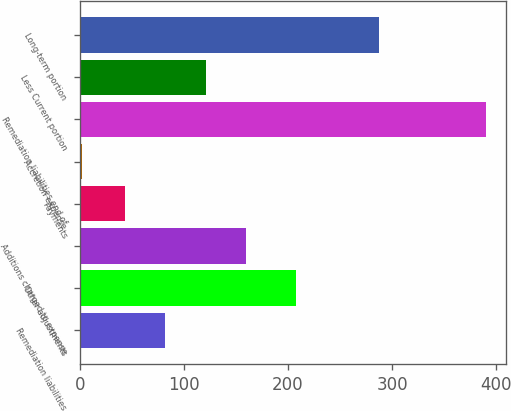<chart> <loc_0><loc_0><loc_500><loc_500><bar_chart><fcel>Remediation liabilities<fcel>Other adjustments<fcel>Additions charged to expense<fcel>Payments<fcel>Accretion expense<fcel>Remediation liabilities end of<fcel>Less Current portion<fcel>Long-term portion<nl><fcel>82.12<fcel>208.1<fcel>159.76<fcel>43.3<fcel>1.7<fcel>389.9<fcel>120.94<fcel>287.1<nl></chart> 